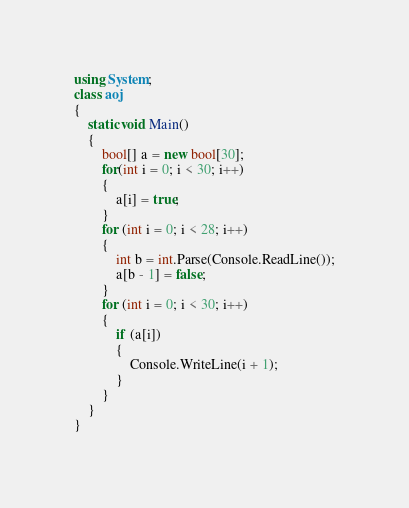<code> <loc_0><loc_0><loc_500><loc_500><_C#_>using System;
class aoj
{
    static void Main()
    {
        bool[] a = new bool[30];
        for(int i = 0; i < 30; i++)
        {
            a[i] = true;
        }
        for (int i = 0; i < 28; i++)
        {
            int b = int.Parse(Console.ReadLine());
            a[b - 1] = false;
        }
        for (int i = 0; i < 30; i++)
        {
            if (a[i])
            {
                Console.WriteLine(i + 1);
            }
        }
    }
}</code> 